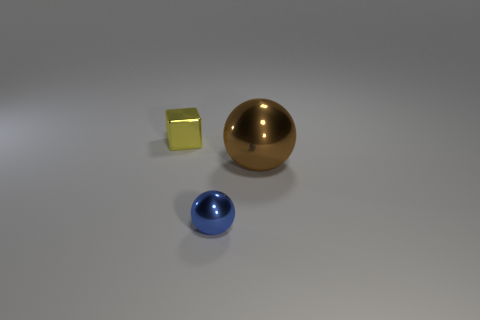Add 3 shiny cubes. How many objects exist? 6 Subtract 1 cubes. How many cubes are left? 0 Subtract all brown spheres. How many spheres are left? 1 Subtract 0 cyan spheres. How many objects are left? 3 Subtract all blocks. How many objects are left? 2 Subtract all brown balls. Subtract all purple cubes. How many balls are left? 1 Subtract all gray spheres. How many brown cubes are left? 0 Subtract all large brown things. Subtract all cubes. How many objects are left? 1 Add 1 large brown shiny objects. How many large brown shiny objects are left? 2 Add 3 tiny yellow metal things. How many tiny yellow metal things exist? 4 